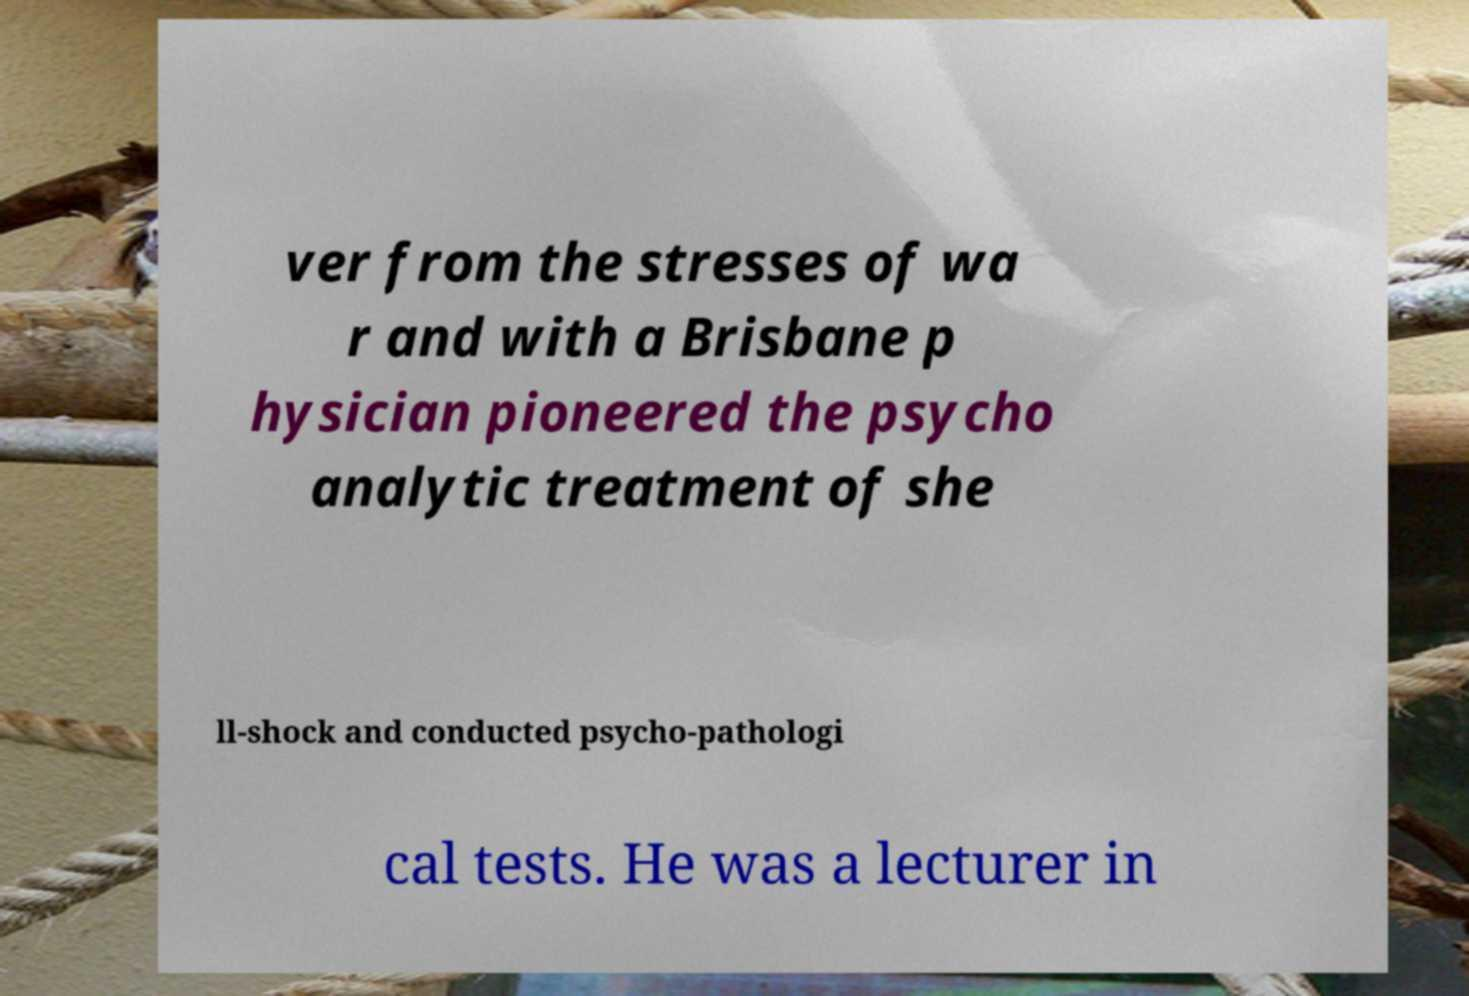Please identify and transcribe the text found in this image. ver from the stresses of wa r and with a Brisbane p hysician pioneered the psycho analytic treatment of she ll-shock and conducted psycho-pathologi cal tests. He was a lecturer in 